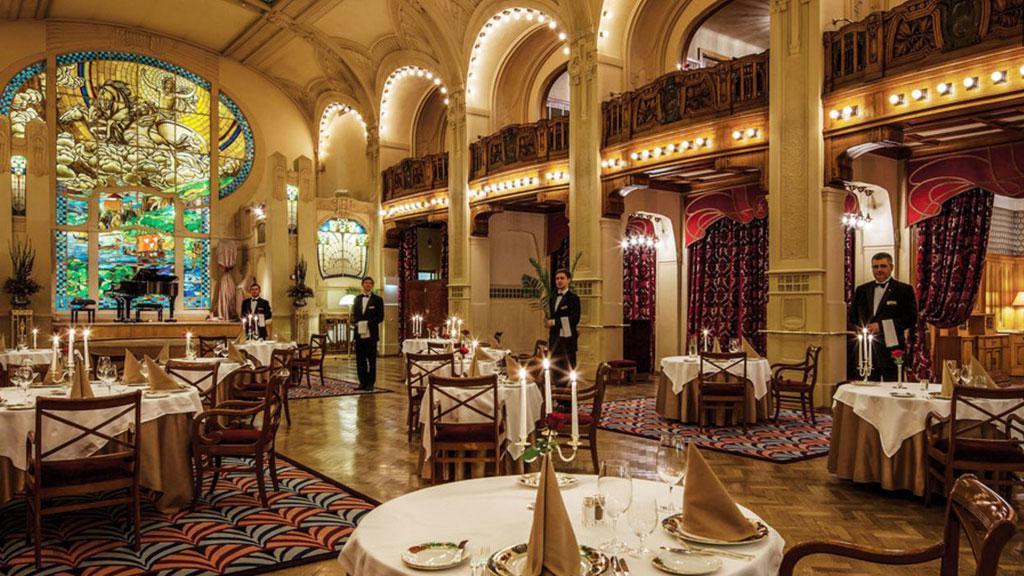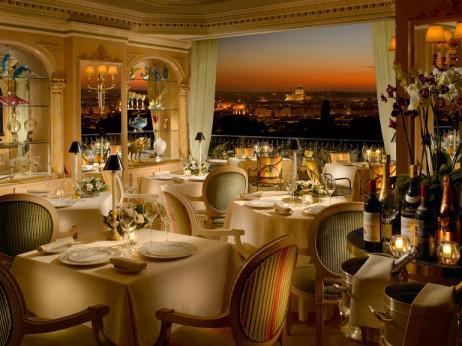The first image is the image on the left, the second image is the image on the right. Considering the images on both sides, is "In one image, a grand piano is at the far end of a room where many tables are set for dinner." valid? Answer yes or no. Yes. 